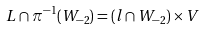<formula> <loc_0><loc_0><loc_500><loc_500>L \cap \pi ^ { - 1 } ( W _ { - 2 } ) = ( l \cap W _ { - 2 } ) \times V</formula> 